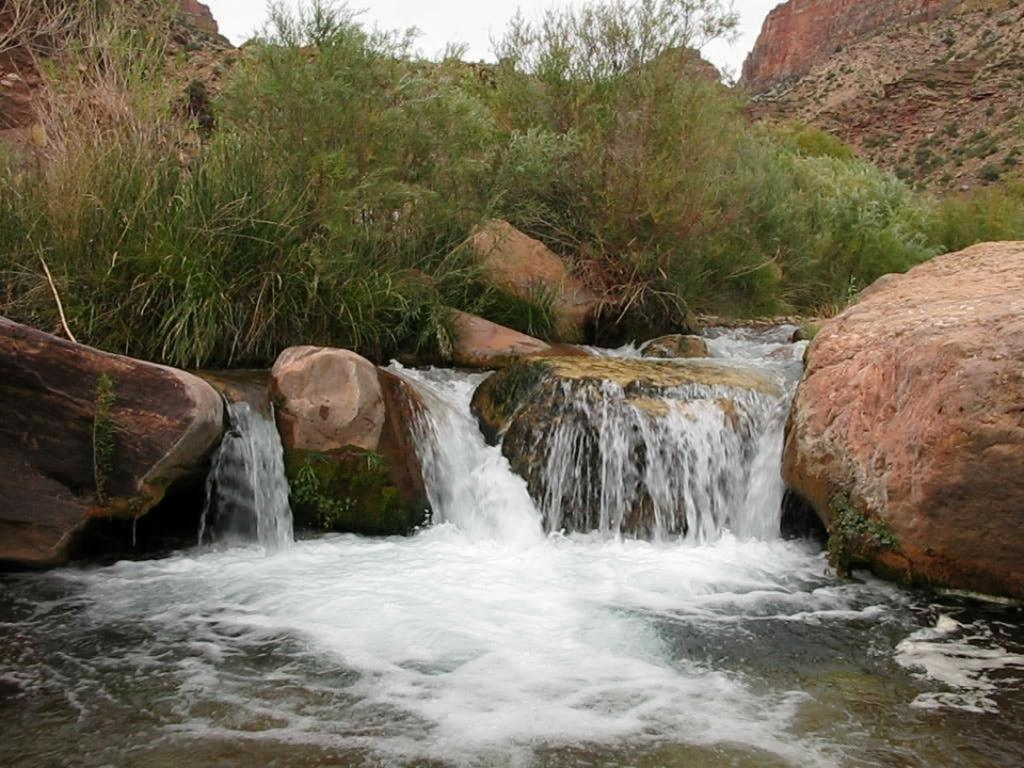What is happening to the water in the image? The water is flowing on rocks in the image. What other natural elements can be seen in the image? There are plants in the image. What can be seen in the background of the image? The sky is visible in the background of the image. What type of collar can be seen on the plants in the image? There are no collars present in the image, as plants do not wear collars. 